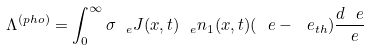<formula> <loc_0><loc_0><loc_500><loc_500>\Lambda ^ { ( p h o ) } = \int _ { 0 } ^ { \infty } { \sigma _ { \ e } J ( x , t ) _ { \ e } n _ { 1 } ( x , t ) ( \ e - \ e _ { t h } ) \frac { d \ e } { \ e } }</formula> 